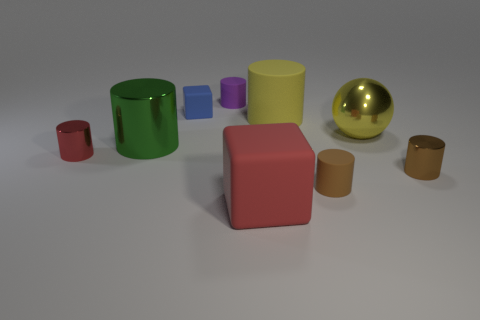What is the color of the small metal cylinder left of the matte block that is in front of the large green metal object?
Keep it short and to the point. Red. Is the yellow metal sphere the same size as the green metallic object?
Make the answer very short. Yes. There is a tiny red thing that is the same shape as the small purple rubber thing; what material is it?
Make the answer very short. Metal. What number of metallic spheres have the same size as the green cylinder?
Your answer should be compact. 1. There is a large cylinder that is made of the same material as the large sphere; what is its color?
Provide a succinct answer. Green. Is the number of yellow spheres less than the number of yellow objects?
Your answer should be compact. Yes. What number of cyan things are either big things or tiny rubber blocks?
Your answer should be compact. 0. What number of small things are both left of the yellow sphere and right of the large red matte object?
Your answer should be very brief. 1. Are the small purple cylinder and the large ball made of the same material?
Provide a short and direct response. No. There is a green object that is the same size as the metal sphere; what shape is it?
Keep it short and to the point. Cylinder. 